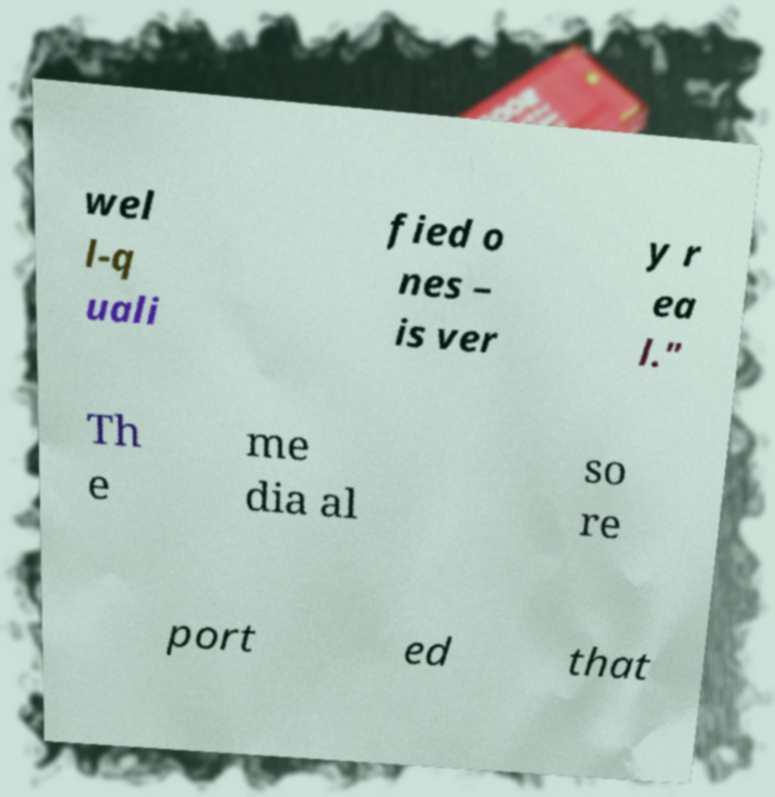Please identify and transcribe the text found in this image. wel l-q uali fied o nes – is ver y r ea l." Th e me dia al so re port ed that 